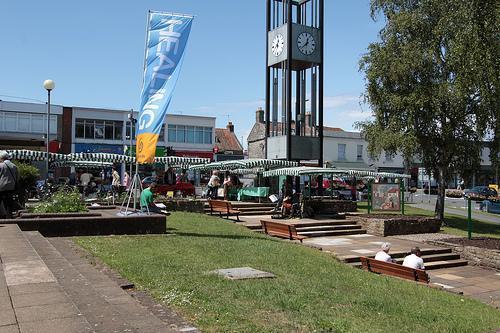How many people are on the bench in the front?
Give a very brief answer. 2. 